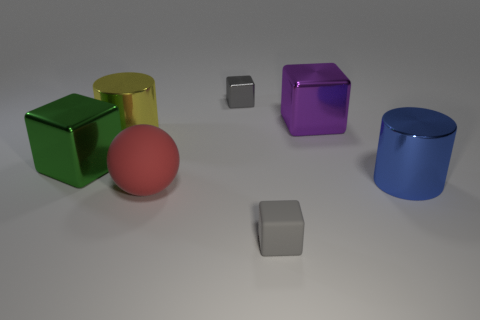Subtract all red cylinders. How many gray cubes are left? 2 Subtract all purple cubes. How many cubes are left? 3 Subtract all tiny rubber cubes. How many cubes are left? 3 Subtract 1 blocks. How many blocks are left? 3 Add 2 red spheres. How many objects exist? 9 Subtract all red blocks. Subtract all gray cylinders. How many blocks are left? 4 Subtract all cylinders. How many objects are left? 5 Subtract all small gray matte things. Subtract all purple metal objects. How many objects are left? 5 Add 4 purple metallic blocks. How many purple metallic blocks are left? 5 Add 7 tiny yellow rubber spheres. How many tiny yellow rubber spheres exist? 7 